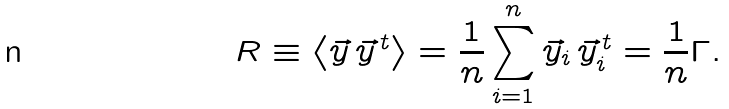<formula> <loc_0><loc_0><loc_500><loc_500>R \equiv \left < \vec { y } \, \vec { y } ^ { \, t } \right > = \frac { 1 } { n } \sum _ { i = 1 } ^ { n } \vec { y } _ { i } \, \vec { y } _ { i } ^ { \, t } = \frac { 1 } { n } \Gamma .</formula> 